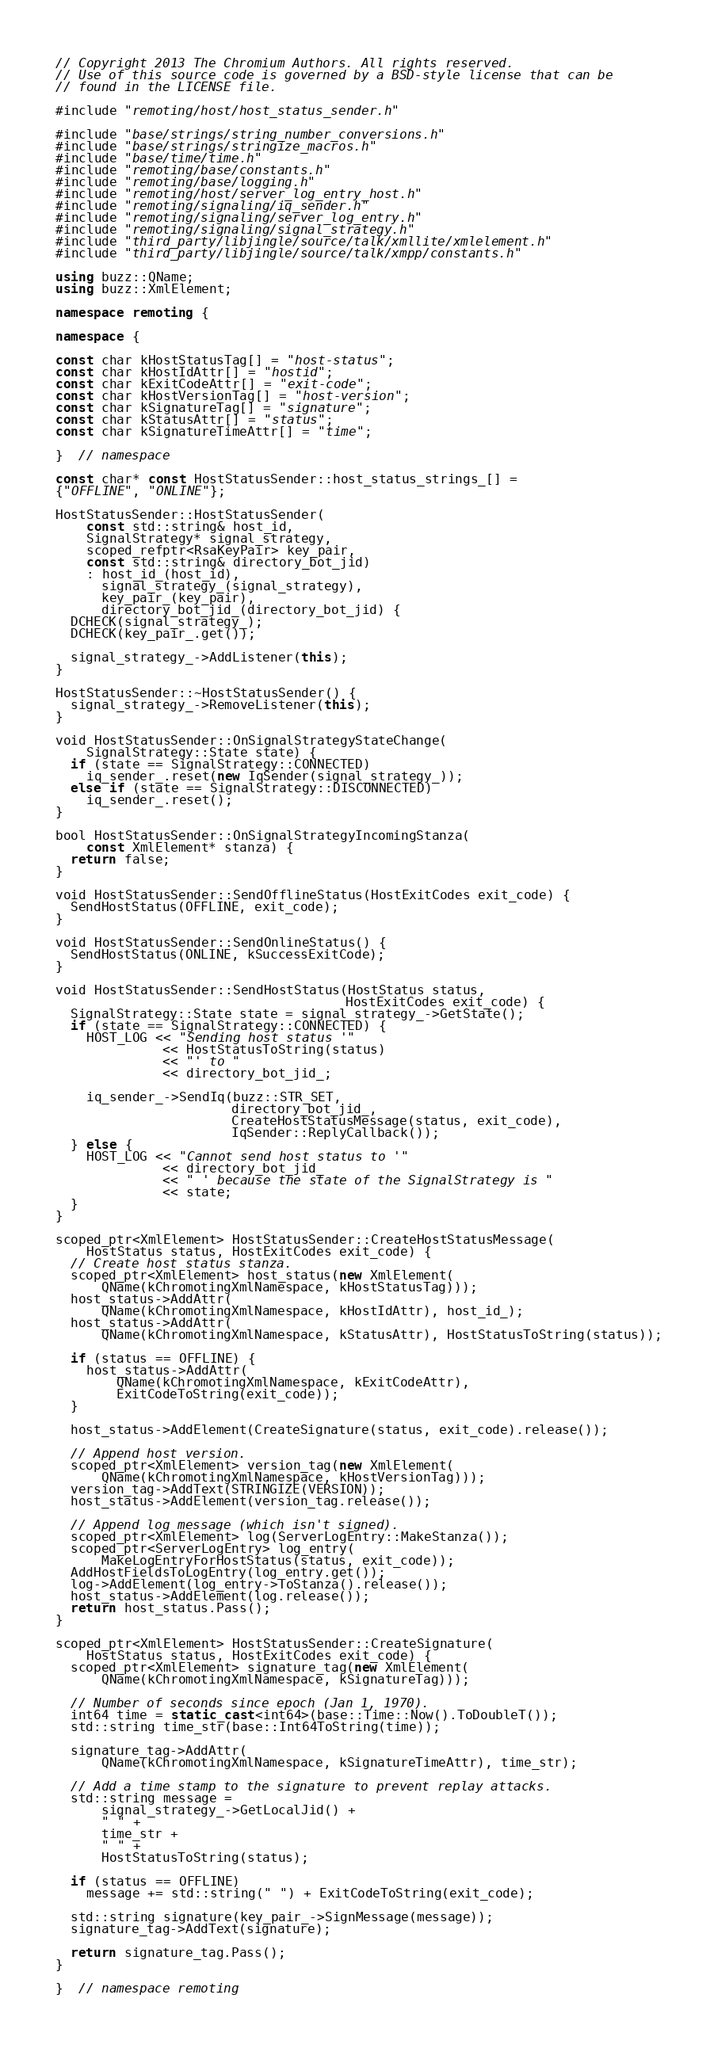Convert code to text. <code><loc_0><loc_0><loc_500><loc_500><_C++_>// Copyright 2013 The Chromium Authors. All rights reserved.
// Use of this source code is governed by a BSD-style license that can be
// found in the LICENSE file.

#include "remoting/host/host_status_sender.h"

#include "base/strings/string_number_conversions.h"
#include "base/strings/stringize_macros.h"
#include "base/time/time.h"
#include "remoting/base/constants.h"
#include "remoting/base/logging.h"
#include "remoting/host/server_log_entry_host.h"
#include "remoting/signaling/iq_sender.h"
#include "remoting/signaling/server_log_entry.h"
#include "remoting/signaling/signal_strategy.h"
#include "third_party/libjingle/source/talk/xmllite/xmlelement.h"
#include "third_party/libjingle/source/talk/xmpp/constants.h"

using buzz::QName;
using buzz::XmlElement;

namespace remoting {

namespace {

const char kHostStatusTag[] = "host-status";
const char kHostIdAttr[] = "hostid";
const char kExitCodeAttr[] = "exit-code";
const char kHostVersionTag[] = "host-version";
const char kSignatureTag[] = "signature";
const char kStatusAttr[] = "status";
const char kSignatureTimeAttr[] = "time";

}  // namespace

const char* const HostStatusSender::host_status_strings_[] =
{"OFFLINE", "ONLINE"};

HostStatusSender::HostStatusSender(
    const std::string& host_id,
    SignalStrategy* signal_strategy,
    scoped_refptr<RsaKeyPair> key_pair,
    const std::string& directory_bot_jid)
    : host_id_(host_id),
      signal_strategy_(signal_strategy),
      key_pair_(key_pair),
      directory_bot_jid_(directory_bot_jid) {
  DCHECK(signal_strategy_);
  DCHECK(key_pair_.get());

  signal_strategy_->AddListener(this);
}

HostStatusSender::~HostStatusSender() {
  signal_strategy_->RemoveListener(this);
}

void HostStatusSender::OnSignalStrategyStateChange(
    SignalStrategy::State state) {
  if (state == SignalStrategy::CONNECTED)
    iq_sender_.reset(new IqSender(signal_strategy_));
  else if (state == SignalStrategy::DISCONNECTED)
    iq_sender_.reset();
}

bool HostStatusSender::OnSignalStrategyIncomingStanza(
    const XmlElement* stanza) {
  return false;
}

void HostStatusSender::SendOfflineStatus(HostExitCodes exit_code) {
  SendHostStatus(OFFLINE, exit_code);
}

void HostStatusSender::SendOnlineStatus() {
  SendHostStatus(ONLINE, kSuccessExitCode);
}

void HostStatusSender::SendHostStatus(HostStatus status,
                                      HostExitCodes exit_code) {
  SignalStrategy::State state = signal_strategy_->GetState();
  if (state == SignalStrategy::CONNECTED) {
    HOST_LOG << "Sending host status '"
              << HostStatusToString(status)
              << "' to "
              << directory_bot_jid_;

    iq_sender_->SendIq(buzz::STR_SET,
                       directory_bot_jid_,
                       CreateHostStatusMessage(status, exit_code),
                       IqSender::ReplyCallback());
  } else {
    HOST_LOG << "Cannot send host status to '"
              << directory_bot_jid_
              << " ' because the state of the SignalStrategy is "
              << state;
  }
}

scoped_ptr<XmlElement> HostStatusSender::CreateHostStatusMessage(
    HostStatus status, HostExitCodes exit_code) {
  // Create host status stanza.
  scoped_ptr<XmlElement> host_status(new XmlElement(
      QName(kChromotingXmlNamespace, kHostStatusTag)));
  host_status->AddAttr(
      QName(kChromotingXmlNamespace, kHostIdAttr), host_id_);
  host_status->AddAttr(
      QName(kChromotingXmlNamespace, kStatusAttr), HostStatusToString(status));

  if (status == OFFLINE) {
    host_status->AddAttr(
        QName(kChromotingXmlNamespace, kExitCodeAttr),
        ExitCodeToString(exit_code));
  }

  host_status->AddElement(CreateSignature(status, exit_code).release());

  // Append host version.
  scoped_ptr<XmlElement> version_tag(new XmlElement(
      QName(kChromotingXmlNamespace, kHostVersionTag)));
  version_tag->AddText(STRINGIZE(VERSION));
  host_status->AddElement(version_tag.release());

  // Append log message (which isn't signed).
  scoped_ptr<XmlElement> log(ServerLogEntry::MakeStanza());
  scoped_ptr<ServerLogEntry> log_entry(
      MakeLogEntryForHostStatus(status, exit_code));
  AddHostFieldsToLogEntry(log_entry.get());
  log->AddElement(log_entry->ToStanza().release());
  host_status->AddElement(log.release());
  return host_status.Pass();
}

scoped_ptr<XmlElement> HostStatusSender::CreateSignature(
    HostStatus status, HostExitCodes exit_code) {
  scoped_ptr<XmlElement> signature_tag(new XmlElement(
      QName(kChromotingXmlNamespace, kSignatureTag)));

  // Number of seconds since epoch (Jan 1, 1970).
  int64 time = static_cast<int64>(base::Time::Now().ToDoubleT());
  std::string time_str(base::Int64ToString(time));

  signature_tag->AddAttr(
      QName(kChromotingXmlNamespace, kSignatureTimeAttr), time_str);

  // Add a time stamp to the signature to prevent replay attacks.
  std::string message =
      signal_strategy_->GetLocalJid() +
      " " +
      time_str +
      " " +
      HostStatusToString(status);

  if (status == OFFLINE)
    message += std::string(" ") + ExitCodeToString(exit_code);

  std::string signature(key_pair_->SignMessage(message));
  signature_tag->AddText(signature);

  return signature_tag.Pass();
}

}  // namespace remoting
</code> 